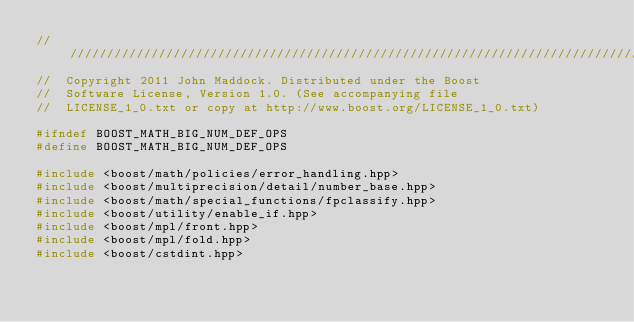Convert code to text. <code><loc_0><loc_0><loc_500><loc_500><_C++_>///////////////////////////////////////////////////////////////////////////////
//  Copyright 2011 John Maddock. Distributed under the Boost
//  Software License, Version 1.0. (See accompanying file
//  LICENSE_1_0.txt or copy at http://www.boost.org/LICENSE_1_0.txt)

#ifndef BOOST_MATH_BIG_NUM_DEF_OPS
#define BOOST_MATH_BIG_NUM_DEF_OPS

#include <boost/math/policies/error_handling.hpp>
#include <boost/multiprecision/detail/number_base.hpp>
#include <boost/math/special_functions/fpclassify.hpp>
#include <boost/utility/enable_if.hpp>
#include <boost/mpl/front.hpp>
#include <boost/mpl/fold.hpp>
#include <boost/cstdint.hpp></code> 